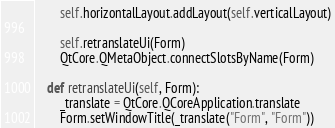Convert code to text. <code><loc_0><loc_0><loc_500><loc_500><_Python_>        self.horizontalLayout.addLayout(self.verticalLayout)

        self.retranslateUi(Form)
        QtCore.QMetaObject.connectSlotsByName(Form)

    def retranslateUi(self, Form):
        _translate = QtCore.QCoreApplication.translate
        Form.setWindowTitle(_translate("Form", "Form"))

</code> 